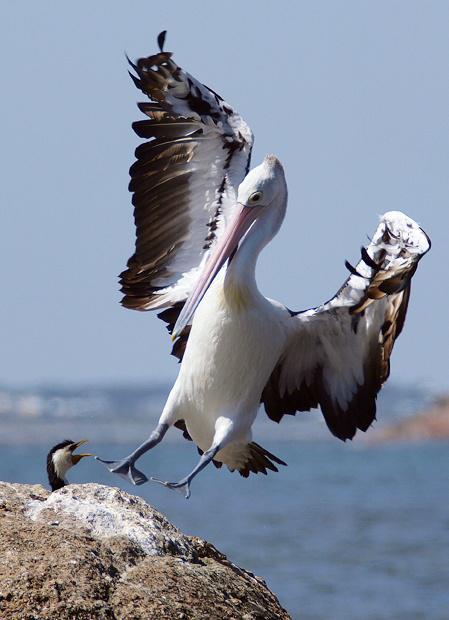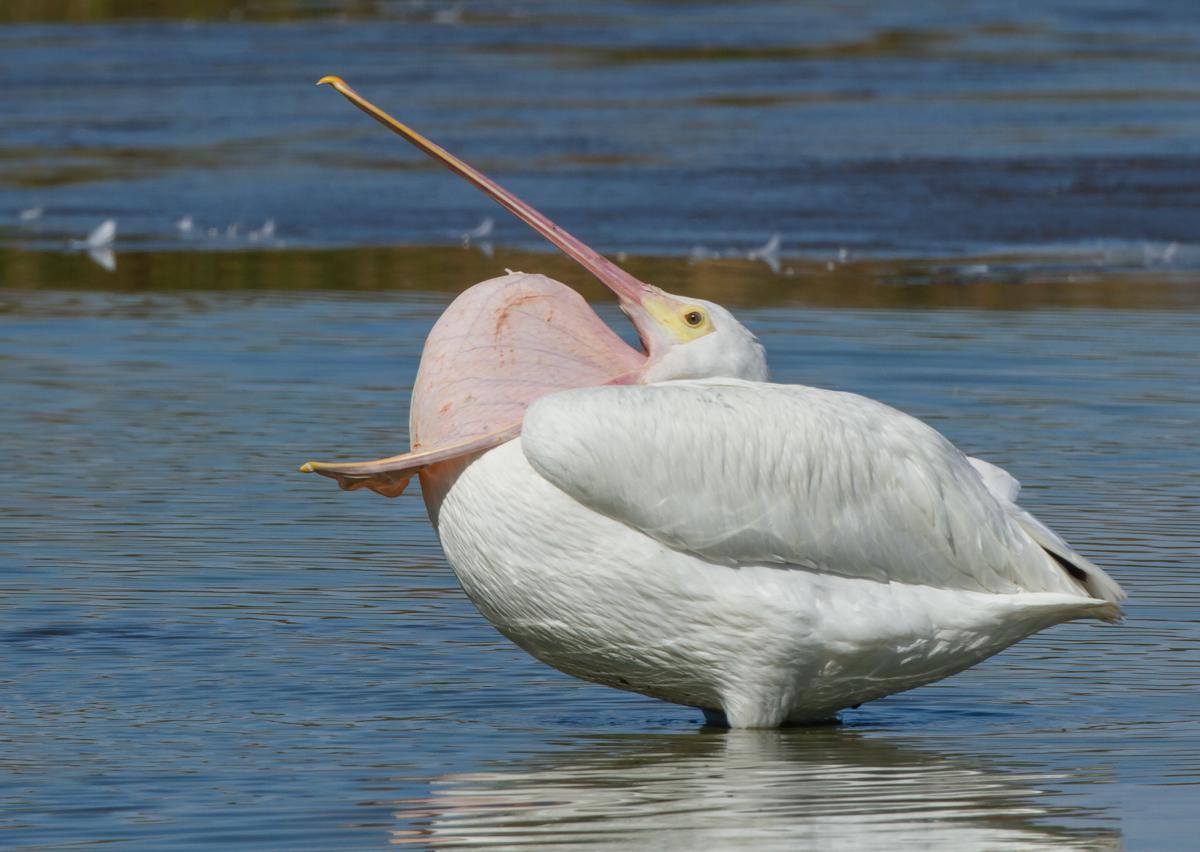The first image is the image on the left, the second image is the image on the right. For the images displayed, is the sentence "At least two pelicans are present in one of the images." factually correct? Answer yes or no. No. The first image is the image on the left, the second image is the image on the right. For the images shown, is this caption "The bird in the image on the right is flying" true? Answer yes or no. No. 